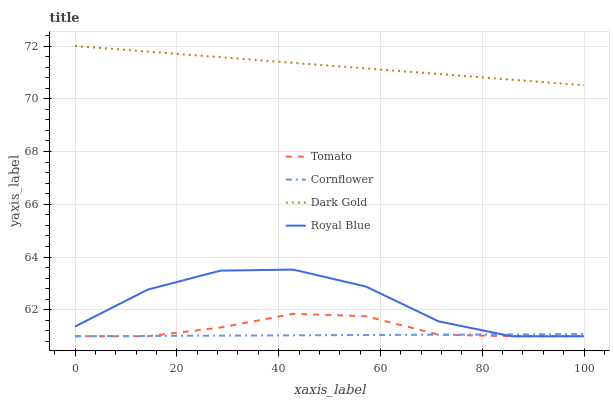Does Cornflower have the minimum area under the curve?
Answer yes or no. Yes. Does Dark Gold have the maximum area under the curve?
Answer yes or no. Yes. Does Royal Blue have the minimum area under the curve?
Answer yes or no. No. Does Royal Blue have the maximum area under the curve?
Answer yes or no. No. Is Cornflower the smoothest?
Answer yes or no. Yes. Is Royal Blue the roughest?
Answer yes or no. Yes. Is Royal Blue the smoothest?
Answer yes or no. No. Is Cornflower the roughest?
Answer yes or no. No. Does Tomato have the lowest value?
Answer yes or no. Yes. Does Dark Gold have the lowest value?
Answer yes or no. No. Does Dark Gold have the highest value?
Answer yes or no. Yes. Does Royal Blue have the highest value?
Answer yes or no. No. Is Cornflower less than Dark Gold?
Answer yes or no. Yes. Is Dark Gold greater than Royal Blue?
Answer yes or no. Yes. Does Tomato intersect Royal Blue?
Answer yes or no. Yes. Is Tomato less than Royal Blue?
Answer yes or no. No. Is Tomato greater than Royal Blue?
Answer yes or no. No. Does Cornflower intersect Dark Gold?
Answer yes or no. No. 